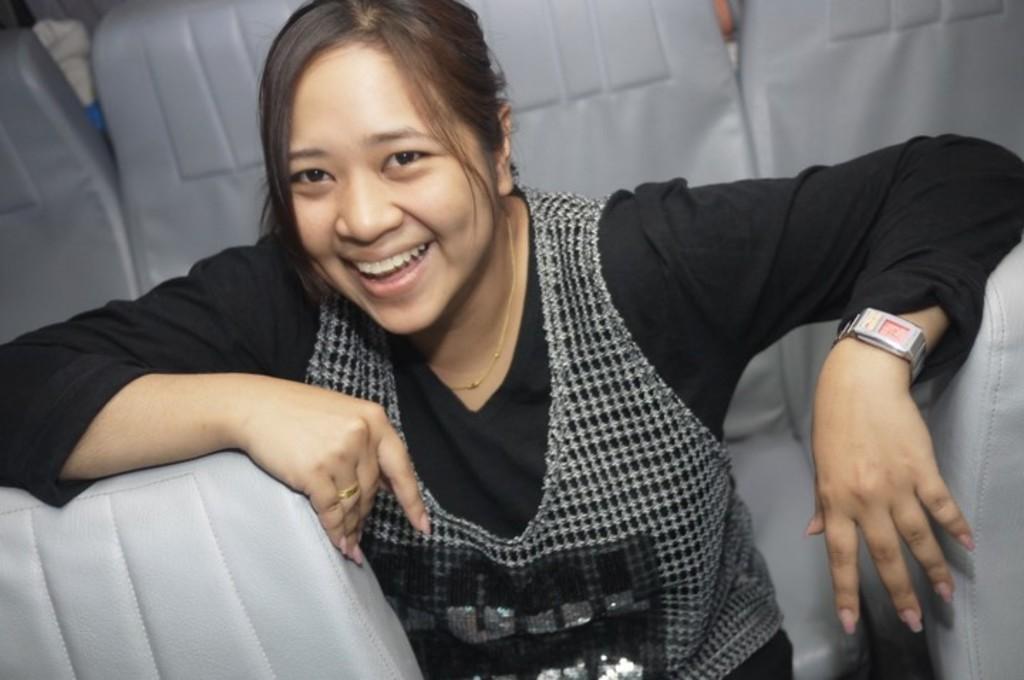Describe this image in one or two sentences. There is a woman sitting on chair and smiling and we can see chairs. 